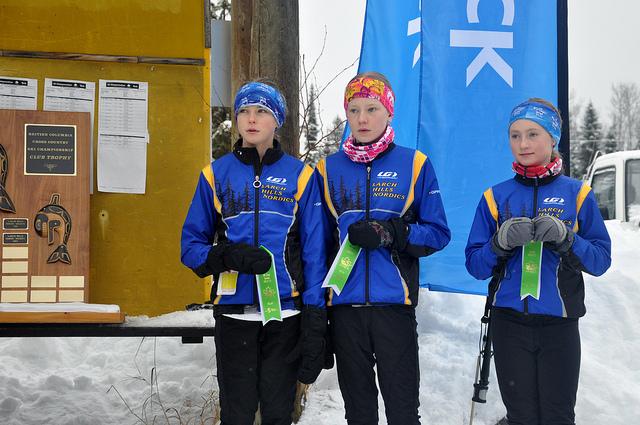Are the girls probably a team that is receiving a sporting award?
Give a very brief answer. Yes. What color are the girls' jackets?
Short answer required. Blue. What color are the ribbons the girls are holding?
Quick response, please. Green. 